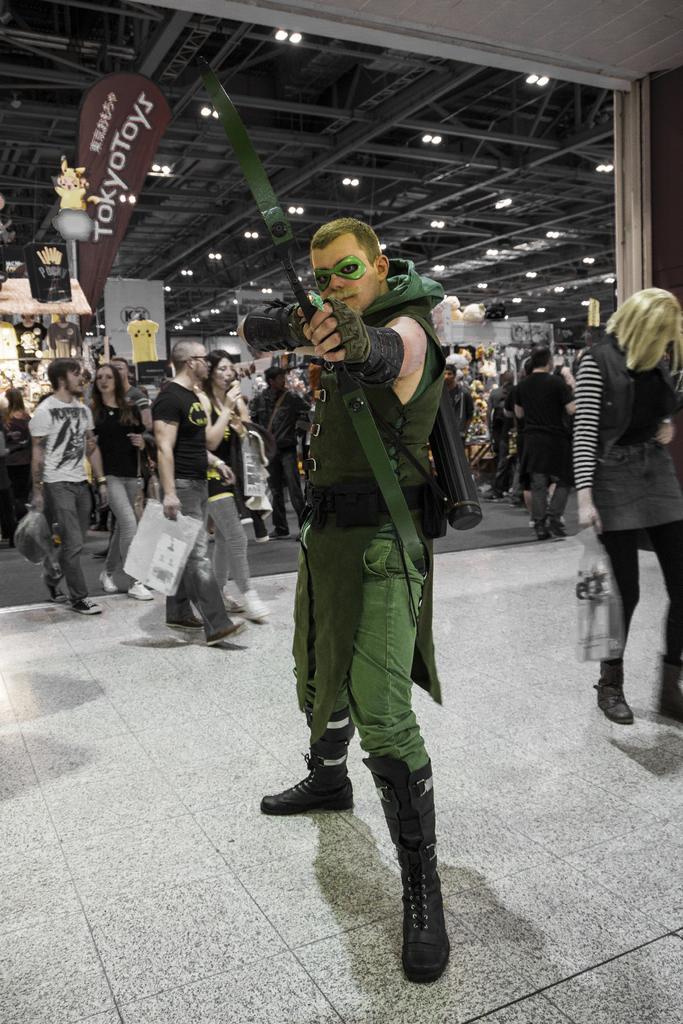How would you summarize this image in a sentence or two? In this image there is a person wearing costumes and standing, in the background there are people, at the top there is ceiling and lights and a banner, on that there is some text. 